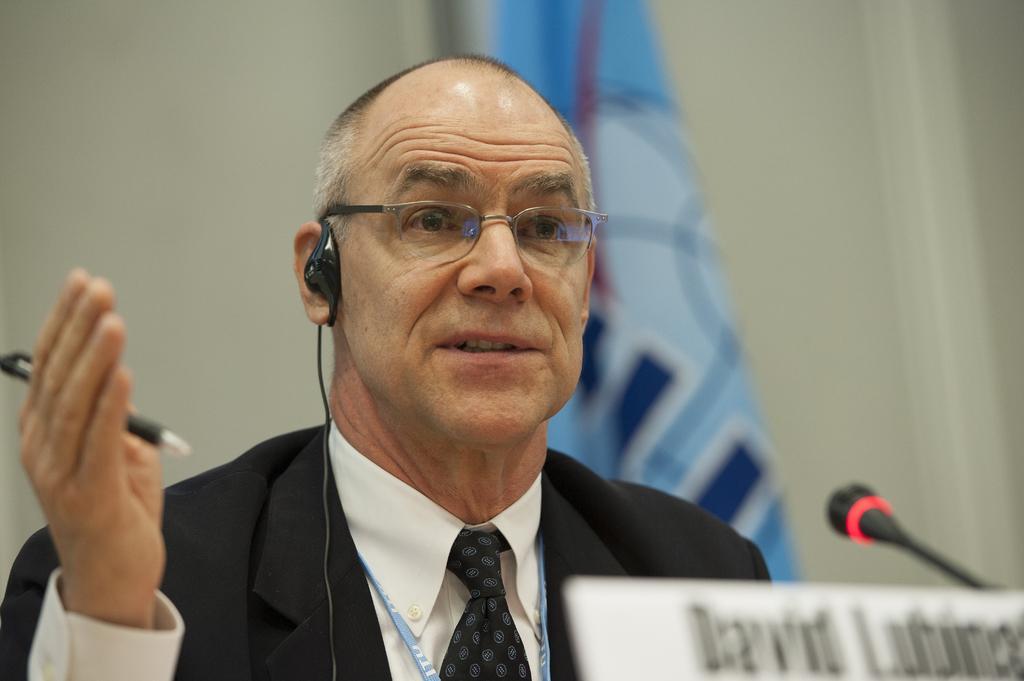In one or two sentences, can you explain what this image depicts? In this image we can see a person holding a pen and talking and in front of him there is a mic and a board with text. In the background, we can see an object which looks like a flag and the wall. 